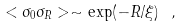Convert formula to latex. <formula><loc_0><loc_0><loc_500><loc_500>< \sigma _ { 0 } \sigma _ { R } > \sim \exp ( - R / \xi ) \ ,</formula> 